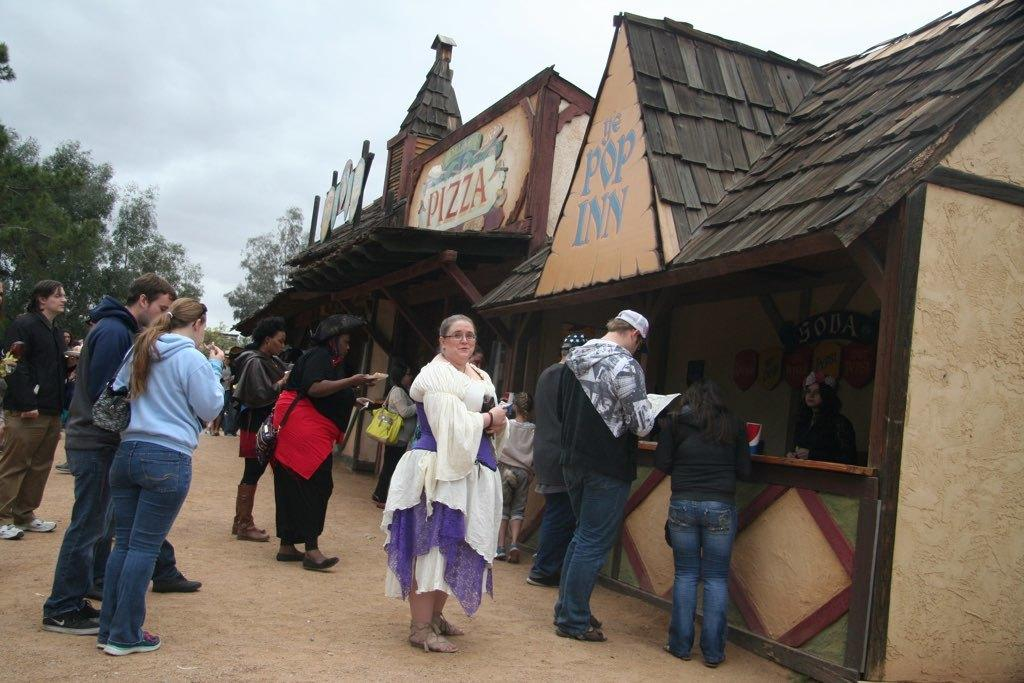What is happening in the image involving the group of people? Some people are standing, while others are eating in the image. What can be seen in the image besides the group of people? There are stalls visible in the image. What is the color of the trees in the background of the image? The trees in the background of the image are green. What is visible in the sky in the background of the image? The sky is visible in the background of the image, and it is white. What type of rice is being used to prepare the beef dish in the image? There is no rice or beef dish present in the image. 